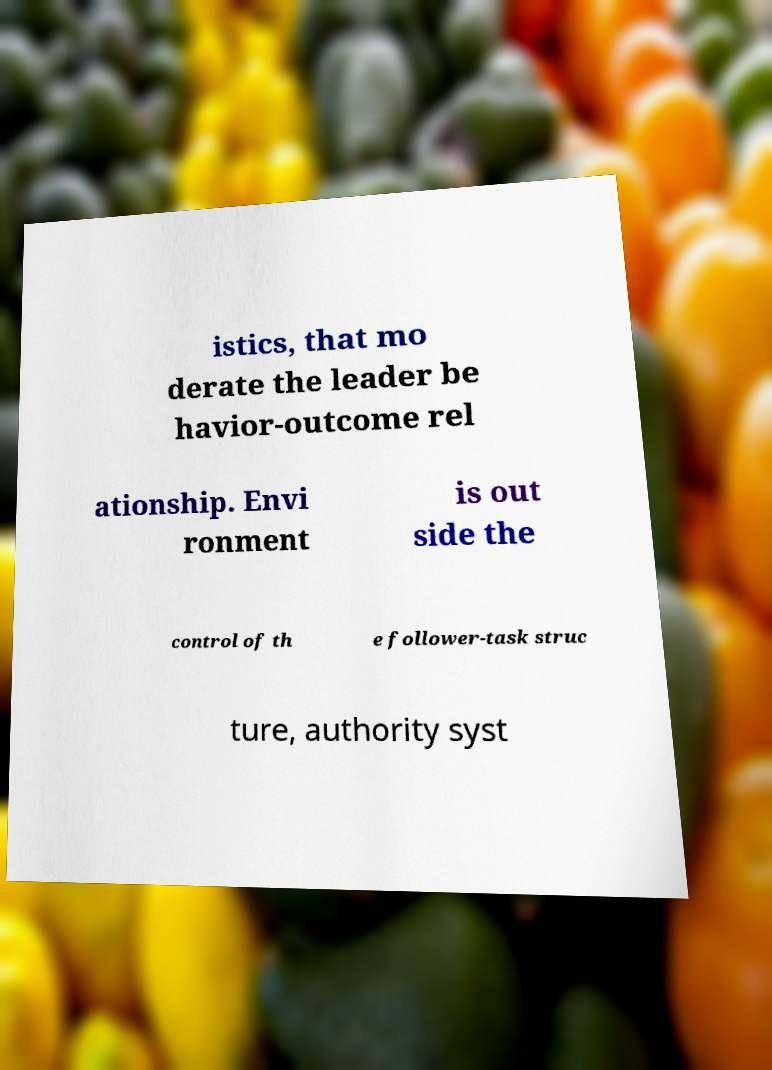Could you assist in decoding the text presented in this image and type it out clearly? istics, that mo derate the leader be havior-outcome rel ationship. Envi ronment is out side the control of th e follower-task struc ture, authority syst 